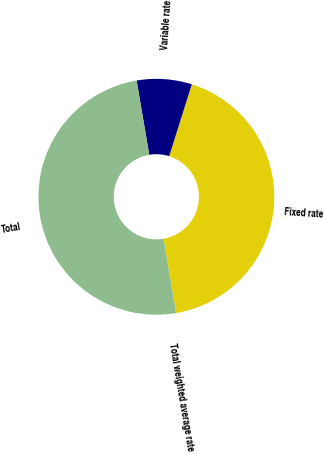<chart> <loc_0><loc_0><loc_500><loc_500><pie_chart><fcel>Fixed rate<fcel>Variable rate<fcel>Total<fcel>Total weighted average rate<nl><fcel>42.46%<fcel>7.54%<fcel>50.0%<fcel>0.0%<nl></chart> 